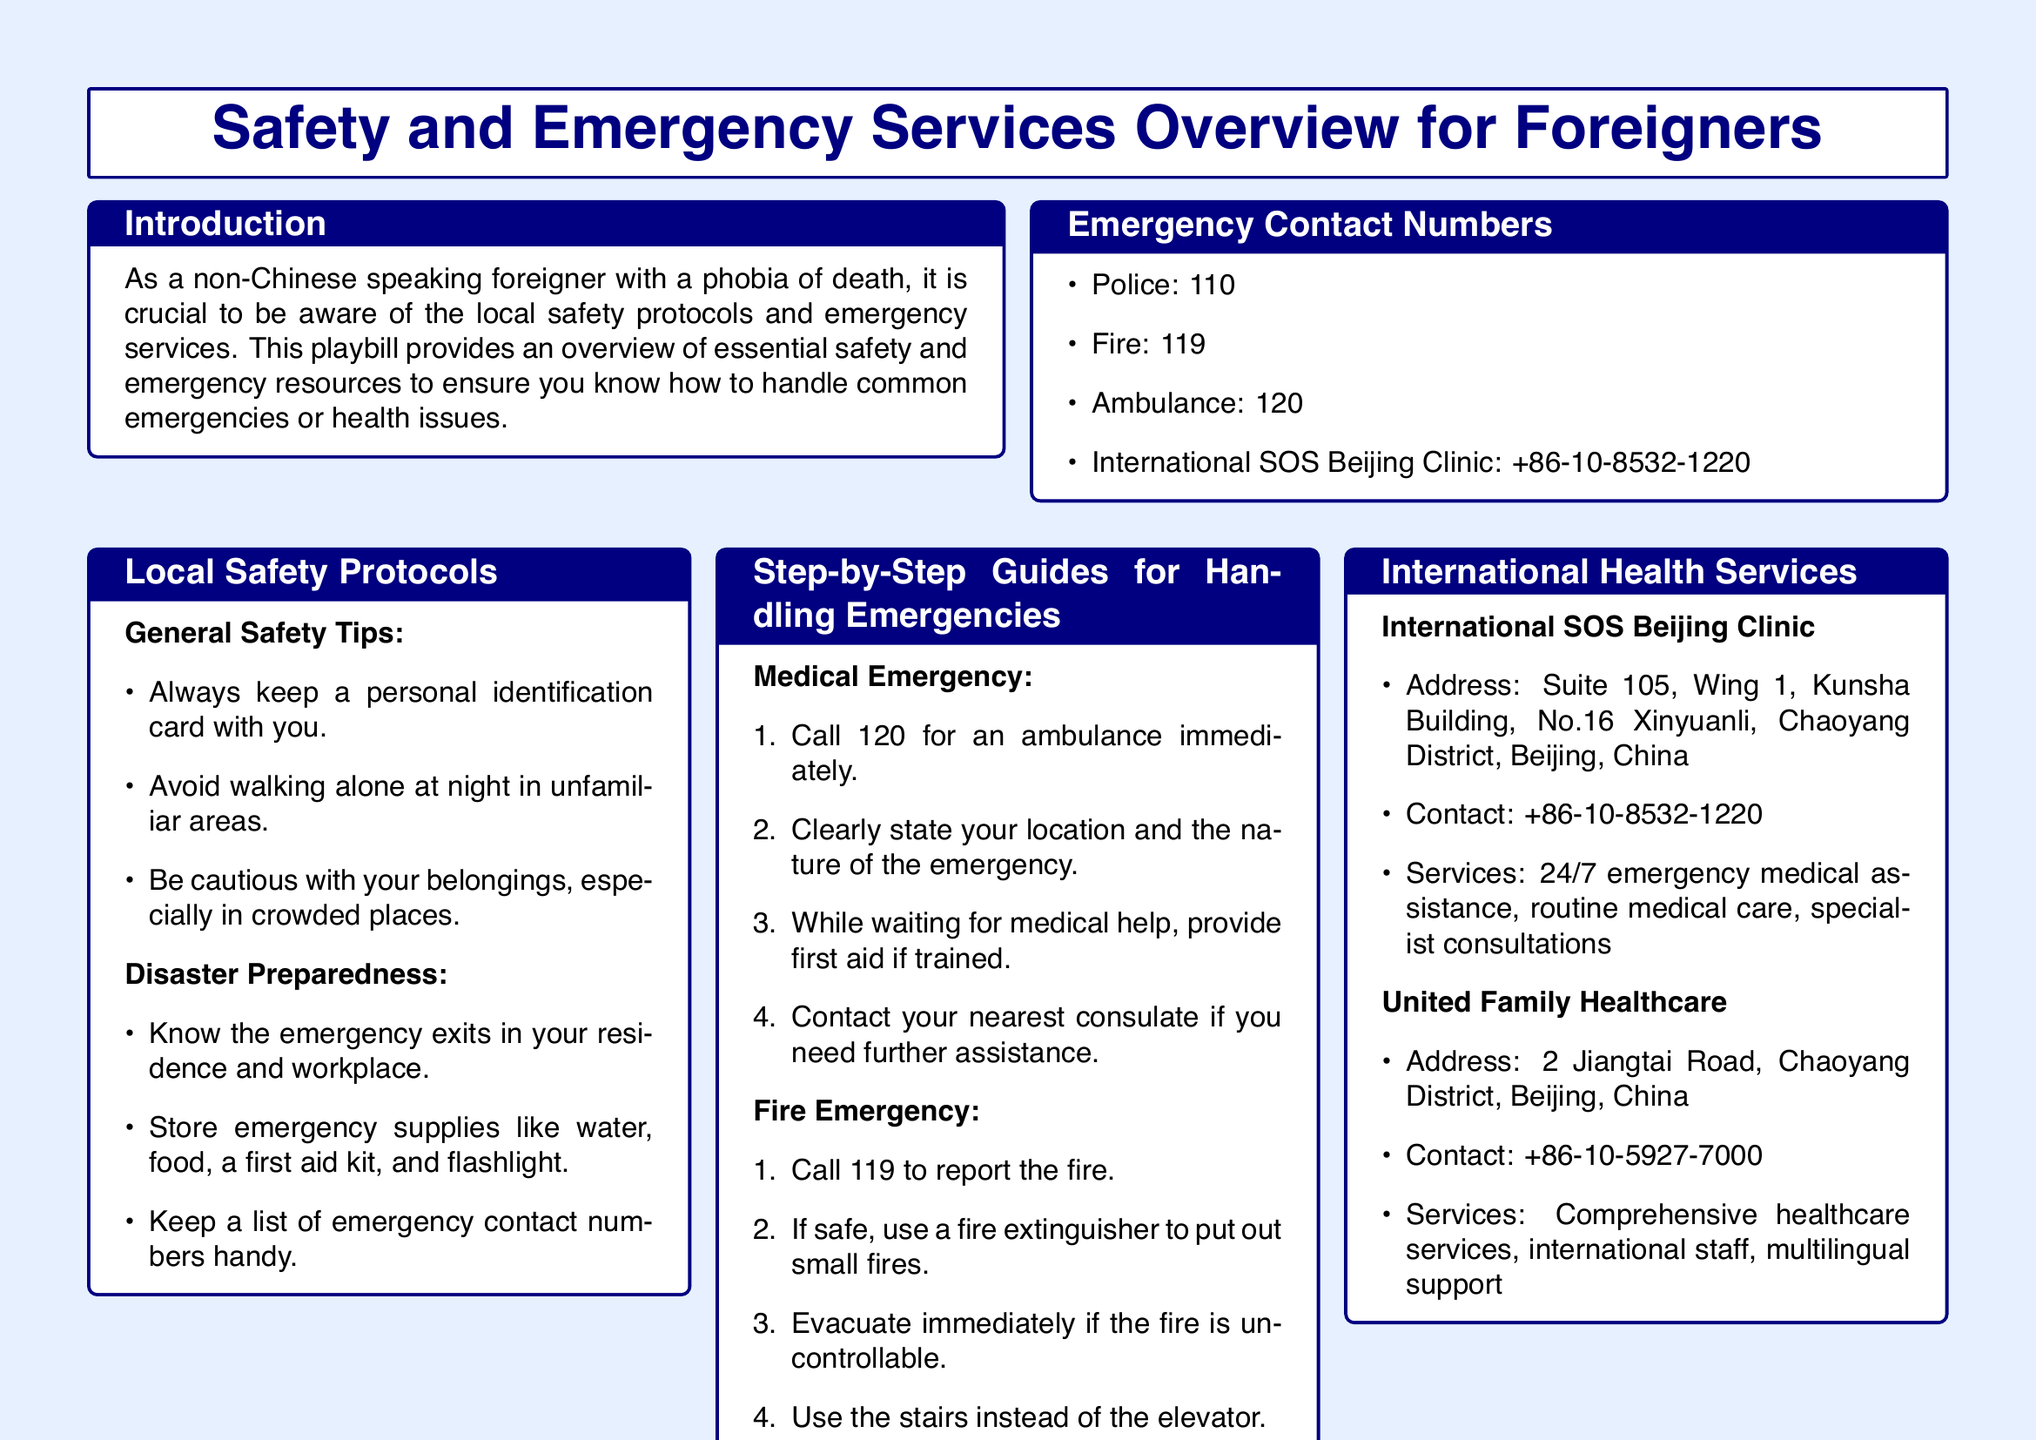What is the emergency number for the police? The document specifies that the emergency number for the police is listed under Emergency Contact Numbers.
Answer: 110 What should you do in a medical emergency? The document outlines a step-by-step guide for handling a medical emergency, which includes calling for an ambulance.
Answer: Call 120 What is the address of the International SOS Beijing Clinic? The address is included in the section about International Health Services, providing specific location information.
Answer: Suite 105, Wing 1, Kunsha Building, No.16 Xinyuanli, Chaoyang District, Beijing, China How many emergency contact numbers are listed? The total number of emergency contact numbers can be counted from the Emergency Contact Numbers section of the document.
Answer: 4 What is one of the general safety tips mentioned? The document provides a list of general safety tips under Local Safety Protocols.
Answer: Always keep a personal identification card with you What should you do if you encounter a personal safety incident? The document offers a step-by-step guide on what to do in case of a personal safety incident.
Answer: Call 110 What service does United Family Healthcare provide? The services provided by United Family Healthcare can be found in the section detailing international health services.
Answer: Comprehensive healthcare services What color is the background of the document? The background color of the document is described as light blue in the formatting section.
Answer: Light blue What type of assistance does International SOS offer? This information is found in the section about International Health Services, highlighting services provided.
Answer: 24/7 emergency medical assistance 